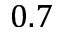<formula> <loc_0><loc_0><loc_500><loc_500>0 . 7</formula> 